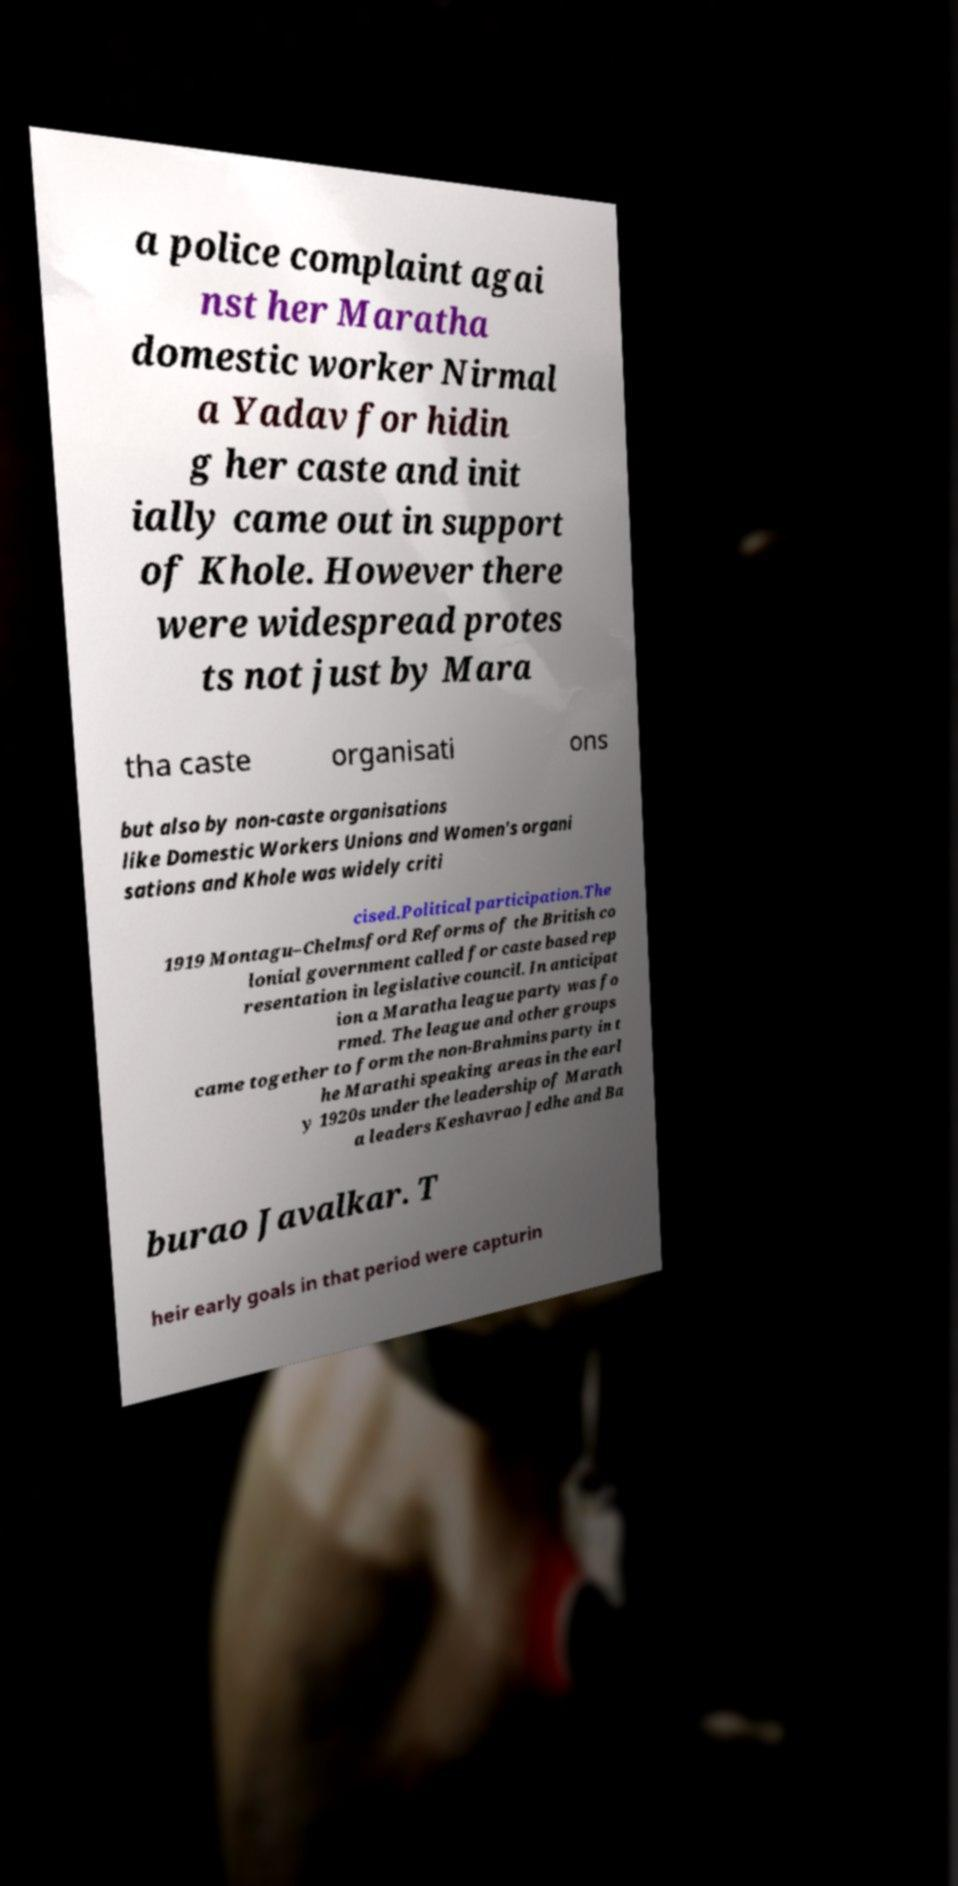I need the written content from this picture converted into text. Can you do that? a police complaint agai nst her Maratha domestic worker Nirmal a Yadav for hidin g her caste and init ially came out in support of Khole. However there were widespread protes ts not just by Mara tha caste organisati ons but also by non-caste organisations like Domestic Workers Unions and Women's organi sations and Khole was widely criti cised.Political participation.The 1919 Montagu–Chelmsford Reforms of the British co lonial government called for caste based rep resentation in legislative council. In anticipat ion a Maratha league party was fo rmed. The league and other groups came together to form the non-Brahmins party in t he Marathi speaking areas in the earl y 1920s under the leadership of Marath a leaders Keshavrao Jedhe and Ba burao Javalkar. T heir early goals in that period were capturin 